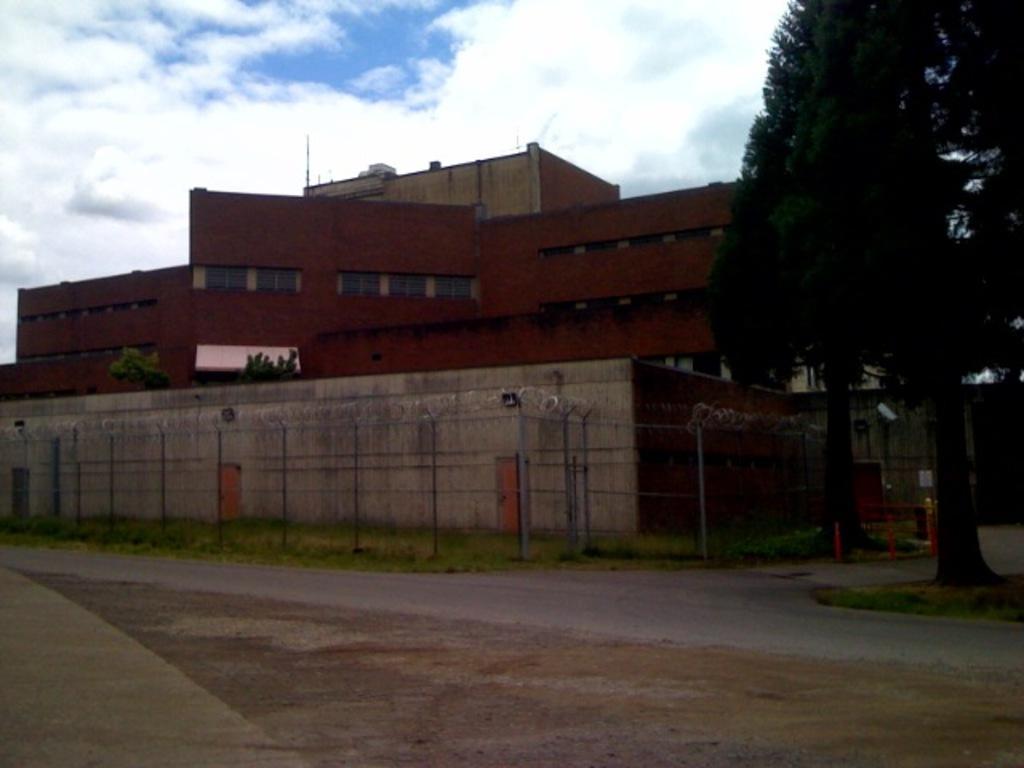Could you give a brief overview of what you see in this image? In this image I can see a tree in green color. Background I can see a building in maroon color and sky in blue and white color. 